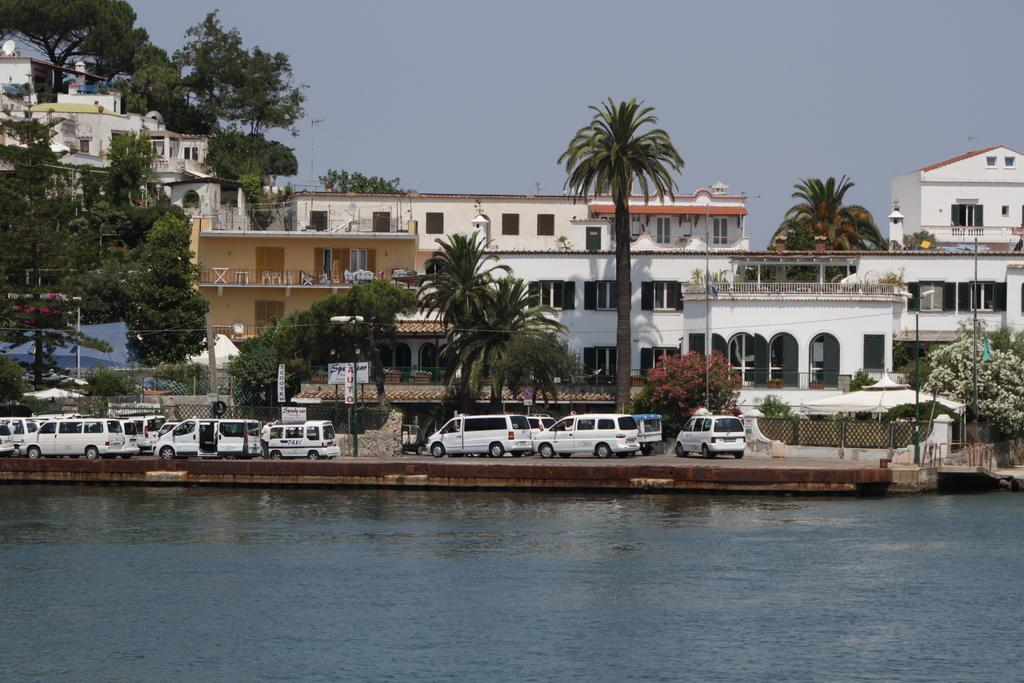What is the main subject in the center of the image? There is water in the center of the image. What can be seen in the background of the image? There are cars, trees, and buildings in the background of the image. What is the condition of the sky in the image? The sky is cloudy in the image. What type of tax can be seen being paid in the image? There is no indication of tax being paid in the image; it features water, cars, trees, buildings, and a cloudy sky. Can you tell me how many beans are present in the image? There are no beans visible in the image. 